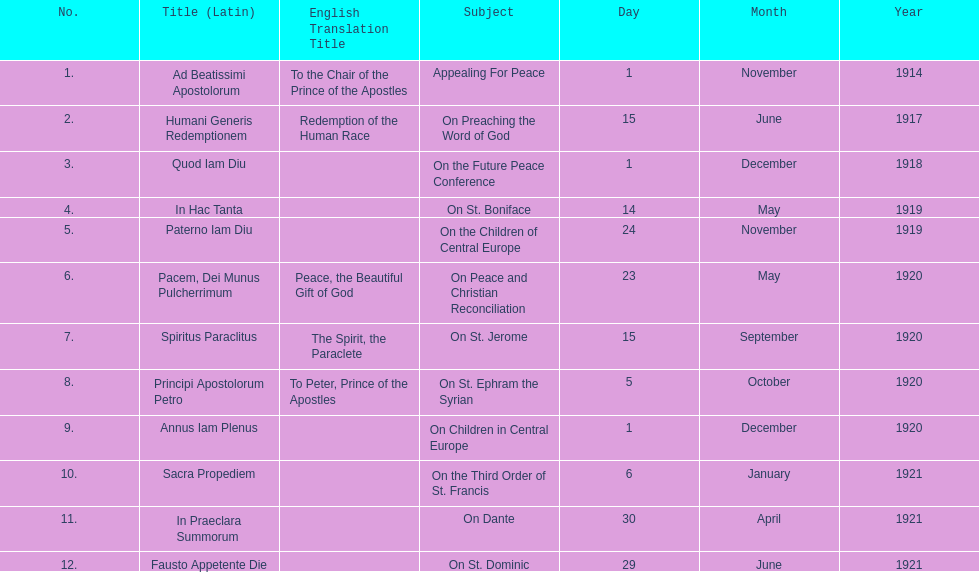What are the number of titles with a date of november? 2. 